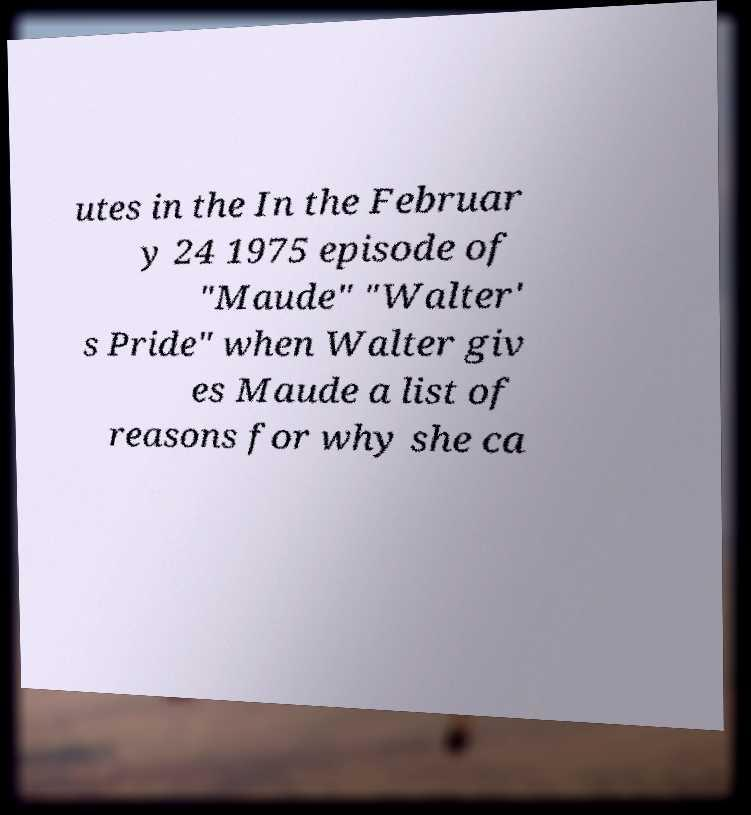Please read and relay the text visible in this image. What does it say? utes in the In the Februar y 24 1975 episode of "Maude" "Walter' s Pride" when Walter giv es Maude a list of reasons for why she ca 